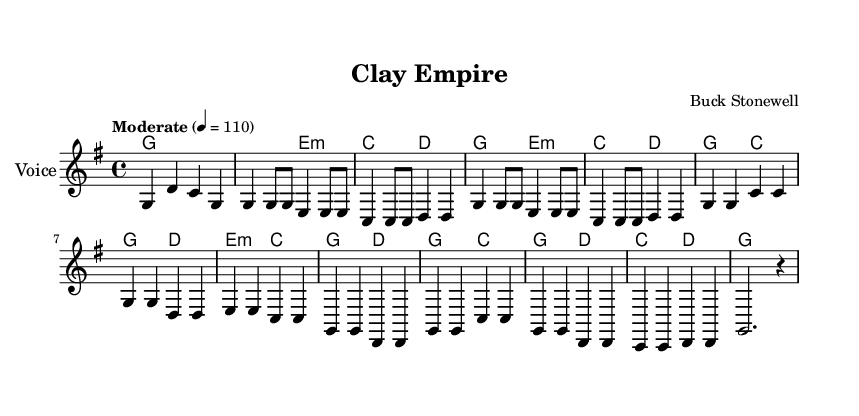What is the key signature of this music? The key signature indicated in the global section is G major, which has one sharp (F#).
Answer: G major What is the time signature of this piece? The time signature is noted in the global section as 4/4, which means there are four beats in each measure.
Answer: 4/4 What is the tempo marking for this song? The tempo is stated as "Moderate" with a metronome marking of 110 beats per minute, indicating a moderate pace.
Answer: 110 What is the instrument indicated for the melody in the score? The instrument is specified to be "Voice" in the staff notation, which suggests this piece is meant to be sung.
Answer: Voice How many measures are in the chorus section? The chorus section consists of four measures, which can be counted directly from the notation provided in the melody.
Answer: 4 What is the overall theme of the lyrics in this piece? The lyrics discuss building an empire and succeeding in international business, particularly in the context of clay. This can be inferred from key phrases in the verse lyrics.
Answer: International business success What is the first note of the melody? The first note in the melody is G, as indicated in the initial measure of the score.
Answer: G 